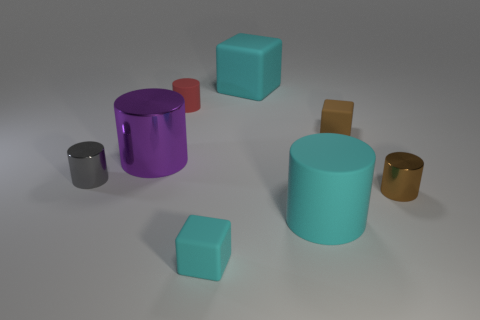How many brown objects are big matte cylinders or big metal cylinders?
Your answer should be compact. 0. Is the color of the tiny rubber thing in front of the tiny gray cylinder the same as the big rubber cube?
Your answer should be compact. Yes. Does the small brown block have the same material as the small gray object?
Your answer should be compact. No. Are there an equal number of red rubber cylinders left of the small brown matte cube and large cubes behind the brown metal object?
Make the answer very short. Yes. There is a big purple object that is the same shape as the gray thing; what is it made of?
Offer a terse response. Metal. There is a small rubber thing that is in front of the large rubber thing that is right of the large cyan rubber object that is behind the tiny brown matte block; what shape is it?
Give a very brief answer. Cube. Are there more purple cylinders to the left of the small brown matte block than tiny purple blocks?
Your answer should be compact. Yes. There is a big cyan rubber object behind the small brown shiny object; does it have the same shape as the gray thing?
Make the answer very short. No. What is the big cylinder that is left of the large cyan cylinder made of?
Your response must be concise. Metal. What number of cyan things have the same shape as the purple thing?
Provide a succinct answer. 1. 